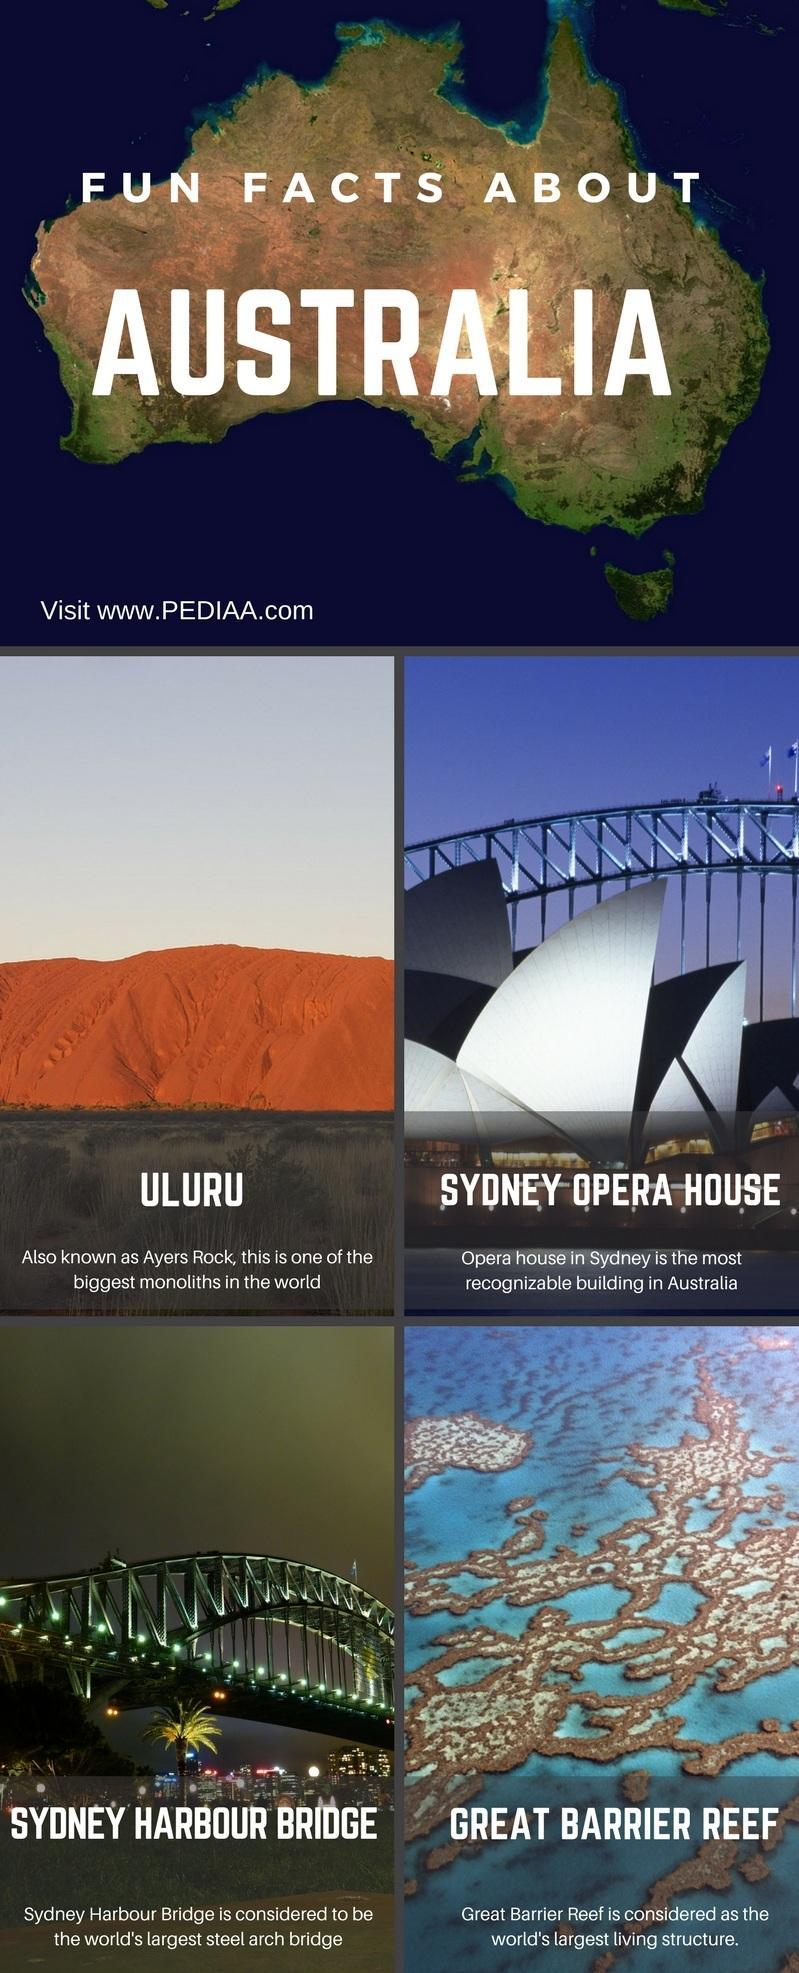How many facts about Australia are in this infographic?
Answer the question with a short phrase. 4 What is the other name of Ayers Rock? Uluru 